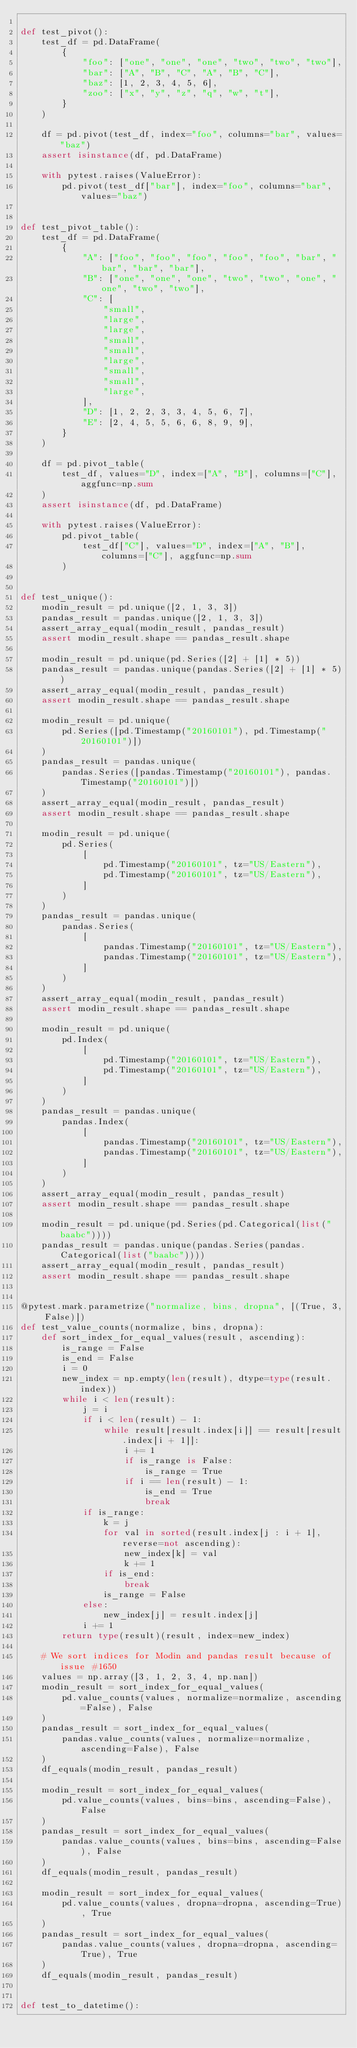<code> <loc_0><loc_0><loc_500><loc_500><_Python_>
def test_pivot():
    test_df = pd.DataFrame(
        {
            "foo": ["one", "one", "one", "two", "two", "two"],
            "bar": ["A", "B", "C", "A", "B", "C"],
            "baz": [1, 2, 3, 4, 5, 6],
            "zoo": ["x", "y", "z", "q", "w", "t"],
        }
    )

    df = pd.pivot(test_df, index="foo", columns="bar", values="baz")
    assert isinstance(df, pd.DataFrame)

    with pytest.raises(ValueError):
        pd.pivot(test_df["bar"], index="foo", columns="bar", values="baz")


def test_pivot_table():
    test_df = pd.DataFrame(
        {
            "A": ["foo", "foo", "foo", "foo", "foo", "bar", "bar", "bar", "bar"],
            "B": ["one", "one", "one", "two", "two", "one", "one", "two", "two"],
            "C": [
                "small",
                "large",
                "large",
                "small",
                "small",
                "large",
                "small",
                "small",
                "large",
            ],
            "D": [1, 2, 2, 3, 3, 4, 5, 6, 7],
            "E": [2, 4, 5, 5, 6, 6, 8, 9, 9],
        }
    )

    df = pd.pivot_table(
        test_df, values="D", index=["A", "B"], columns=["C"], aggfunc=np.sum
    )
    assert isinstance(df, pd.DataFrame)

    with pytest.raises(ValueError):
        pd.pivot_table(
            test_df["C"], values="D", index=["A", "B"], columns=["C"], aggfunc=np.sum
        )


def test_unique():
    modin_result = pd.unique([2, 1, 3, 3])
    pandas_result = pandas.unique([2, 1, 3, 3])
    assert_array_equal(modin_result, pandas_result)
    assert modin_result.shape == pandas_result.shape

    modin_result = pd.unique(pd.Series([2] + [1] * 5))
    pandas_result = pandas.unique(pandas.Series([2] + [1] * 5))
    assert_array_equal(modin_result, pandas_result)
    assert modin_result.shape == pandas_result.shape

    modin_result = pd.unique(
        pd.Series([pd.Timestamp("20160101"), pd.Timestamp("20160101")])
    )
    pandas_result = pandas.unique(
        pandas.Series([pandas.Timestamp("20160101"), pandas.Timestamp("20160101")])
    )
    assert_array_equal(modin_result, pandas_result)
    assert modin_result.shape == pandas_result.shape

    modin_result = pd.unique(
        pd.Series(
            [
                pd.Timestamp("20160101", tz="US/Eastern"),
                pd.Timestamp("20160101", tz="US/Eastern"),
            ]
        )
    )
    pandas_result = pandas.unique(
        pandas.Series(
            [
                pandas.Timestamp("20160101", tz="US/Eastern"),
                pandas.Timestamp("20160101", tz="US/Eastern"),
            ]
        )
    )
    assert_array_equal(modin_result, pandas_result)
    assert modin_result.shape == pandas_result.shape

    modin_result = pd.unique(
        pd.Index(
            [
                pd.Timestamp("20160101", tz="US/Eastern"),
                pd.Timestamp("20160101", tz="US/Eastern"),
            ]
        )
    )
    pandas_result = pandas.unique(
        pandas.Index(
            [
                pandas.Timestamp("20160101", tz="US/Eastern"),
                pandas.Timestamp("20160101", tz="US/Eastern"),
            ]
        )
    )
    assert_array_equal(modin_result, pandas_result)
    assert modin_result.shape == pandas_result.shape

    modin_result = pd.unique(pd.Series(pd.Categorical(list("baabc"))))
    pandas_result = pandas.unique(pandas.Series(pandas.Categorical(list("baabc"))))
    assert_array_equal(modin_result, pandas_result)
    assert modin_result.shape == pandas_result.shape


@pytest.mark.parametrize("normalize, bins, dropna", [(True, 3, False)])
def test_value_counts(normalize, bins, dropna):
    def sort_index_for_equal_values(result, ascending):
        is_range = False
        is_end = False
        i = 0
        new_index = np.empty(len(result), dtype=type(result.index))
        while i < len(result):
            j = i
            if i < len(result) - 1:
                while result[result.index[i]] == result[result.index[i + 1]]:
                    i += 1
                    if is_range is False:
                        is_range = True
                    if i == len(result) - 1:
                        is_end = True
                        break
            if is_range:
                k = j
                for val in sorted(result.index[j : i + 1], reverse=not ascending):
                    new_index[k] = val
                    k += 1
                if is_end:
                    break
                is_range = False
            else:
                new_index[j] = result.index[j]
            i += 1
        return type(result)(result, index=new_index)

    # We sort indices for Modin and pandas result because of issue #1650
    values = np.array([3, 1, 2, 3, 4, np.nan])
    modin_result = sort_index_for_equal_values(
        pd.value_counts(values, normalize=normalize, ascending=False), False
    )
    pandas_result = sort_index_for_equal_values(
        pandas.value_counts(values, normalize=normalize, ascending=False), False
    )
    df_equals(modin_result, pandas_result)

    modin_result = sort_index_for_equal_values(
        pd.value_counts(values, bins=bins, ascending=False), False
    )
    pandas_result = sort_index_for_equal_values(
        pandas.value_counts(values, bins=bins, ascending=False), False
    )
    df_equals(modin_result, pandas_result)

    modin_result = sort_index_for_equal_values(
        pd.value_counts(values, dropna=dropna, ascending=True), True
    )
    pandas_result = sort_index_for_equal_values(
        pandas.value_counts(values, dropna=dropna, ascending=True), True
    )
    df_equals(modin_result, pandas_result)


def test_to_datetime():</code> 